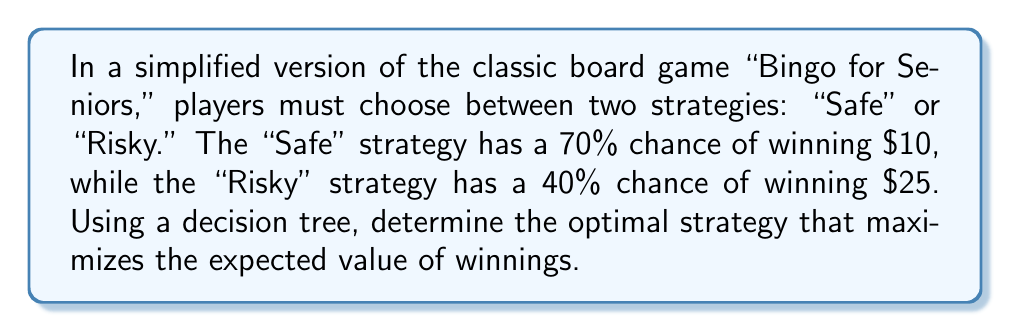Give your solution to this math problem. To solve this problem, we'll use a decision tree to calculate the expected value of each strategy:

1. Let's start with the "Safe" strategy:
   - Probability of winning: 70% = 0.7
   - Probability of losing: 30% = 0.3
   - Winnings: $10

   Expected value: $E_{Safe} = 0.7 \times \$10 + 0.3 \times \$0 = \$7$

2. Now, let's calculate the "Risky" strategy:
   - Probability of winning: 40% = 0.4
   - Probability of losing: 60% = 0.6
   - Winnings: $25

   Expected value: $E_{Risky} = 0.4 \times \$25 + 0.6 \times \$0 = \$10$

3. Decision tree representation:

[asy]
unitsize(1cm);

draw((0,0)--(2,1), arrow=Arrow());
draw((0,0)--(2,-1), arrow=Arrow());

label("Start", (0,0), W);
label("Safe", (1,0.7), NW);
label("Risky", (1,-0.7), SW);

label("$E_{Safe} = \$7$", (2.5,1), E);
label("$E_{Risky} = \$10$", (2.5,-1), E);
[/asy]

4. Compare the expected values:
   $E_{Safe} = \$7 < E_{Risky} = \$10$

Therefore, the optimal strategy is the "Risky" strategy, as it has a higher expected value of winnings.
Answer: The optimal strategy is the "Risky" strategy, with an expected value of $10. 